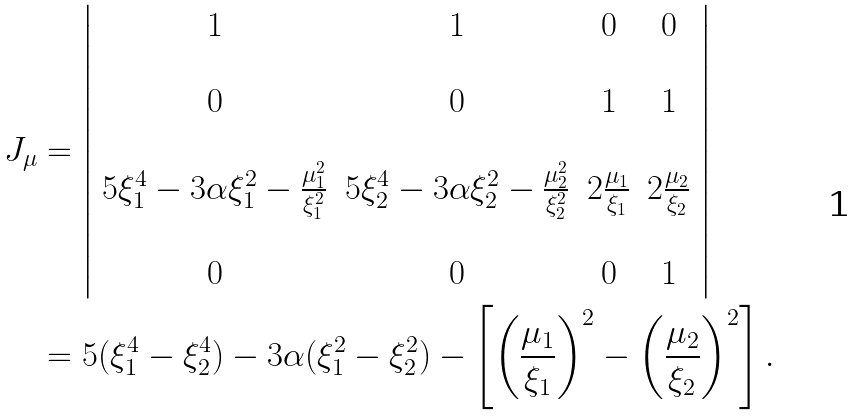Convert formula to latex. <formula><loc_0><loc_0><loc_500><loc_500>J _ { \mu } & = \left | \begin{array} { c c c c } 1 & 1 & 0 & 0 \\ \, & \, & \, & \, \\ 0 & 0 & 1 & 1 \\ \, & \, & \, & \, \\ 5 \xi ^ { 4 } _ { 1 } - 3 \alpha \xi _ { 1 } ^ { 2 } - \frac { \mu _ { 1 } ^ { 2 } } { \xi _ { 1 } ^ { 2 } } & 5 \xi ^ { 4 } _ { 2 } - 3 \alpha \xi _ { 2 } ^ { 2 } - \frac { \mu _ { 2 } ^ { 2 } } { \xi _ { 2 } ^ { 2 } } & 2 \frac { \mu _ { 1 } } { \xi _ { 1 } } & 2 \frac { \mu _ { 2 } } { \xi _ { 2 } } \\ \, & \, & \, & \, \\ 0 & 0 & 0 & 1 \end{array} \right | \\ & = 5 ( \xi _ { 1 } ^ { 4 } - \xi _ { 2 } ^ { 4 } ) - 3 \alpha ( \xi _ { 1 } ^ { 2 } - \xi _ { 2 } ^ { 2 } ) - \left [ \left ( \frac { \mu _ { 1 } } { \xi _ { 1 } } \right ) ^ { 2 } - \left ( \frac { \mu _ { 2 } } { \xi _ { 2 } } \right ) ^ { 2 } \right ] .</formula> 